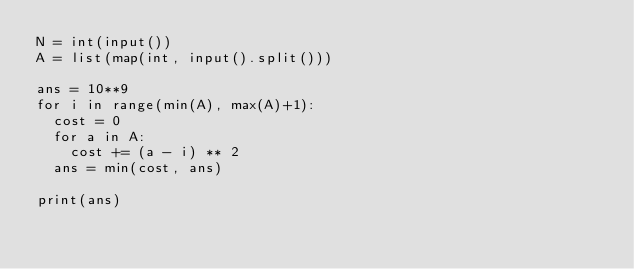Convert code to text. <code><loc_0><loc_0><loc_500><loc_500><_Python_>N = int(input())
A = list(map(int, input().split()))

ans = 10**9
for i in range(min(A), max(A)+1):
  cost = 0
  for a in A:
    cost += (a - i) ** 2
  ans = min(cost, ans)

print(ans)</code> 